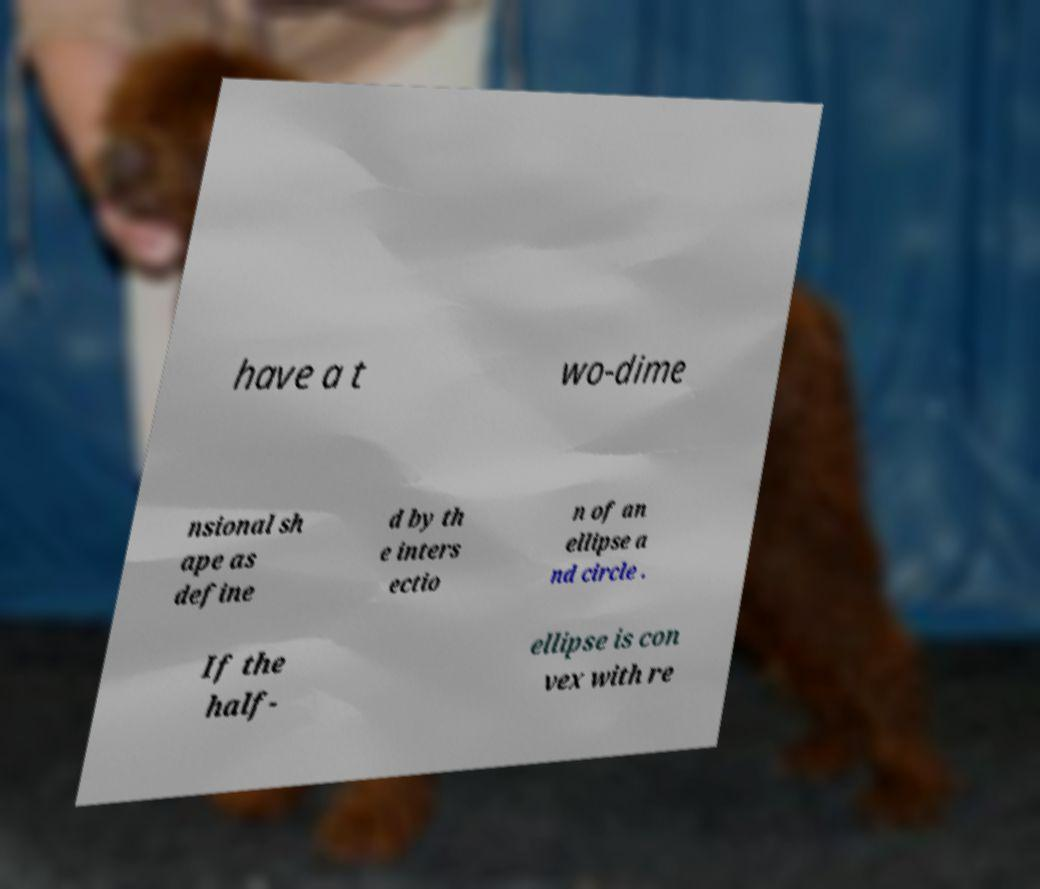Could you extract and type out the text from this image? have a t wo-dime nsional sh ape as define d by th e inters ectio n of an ellipse a nd circle . If the half- ellipse is con vex with re 